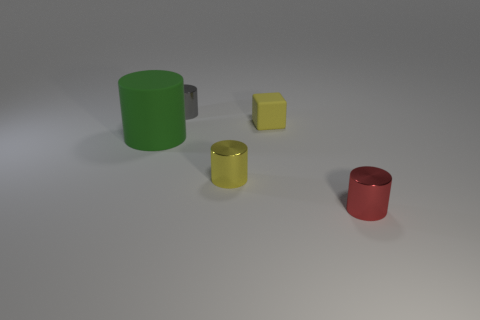Is the gray cylinder made of the same material as the cylinder that is to the left of the gray object?
Offer a terse response. No. What is the cylinder that is behind the large rubber object made of?
Keep it short and to the point. Metal. What size is the red object?
Offer a terse response. Small. There is a object right of the small yellow rubber block; does it have the same size as the yellow thing in front of the tiny yellow rubber thing?
Make the answer very short. Yes. The green object that is the same shape as the gray metallic thing is what size?
Your answer should be very brief. Large. There is a yellow shiny cylinder; does it have the same size as the shiny cylinder on the left side of the small yellow metal object?
Give a very brief answer. Yes. Are there any yellow rubber objects on the right side of the rubber object behind the green cylinder?
Make the answer very short. No. What shape is the thing on the right side of the cube?
Your answer should be compact. Cylinder. There is a cylinder that is the same color as the tiny rubber object; what is its material?
Provide a succinct answer. Metal. There is a object that is right of the yellow object that is behind the small yellow cylinder; what color is it?
Provide a succinct answer. Red. 